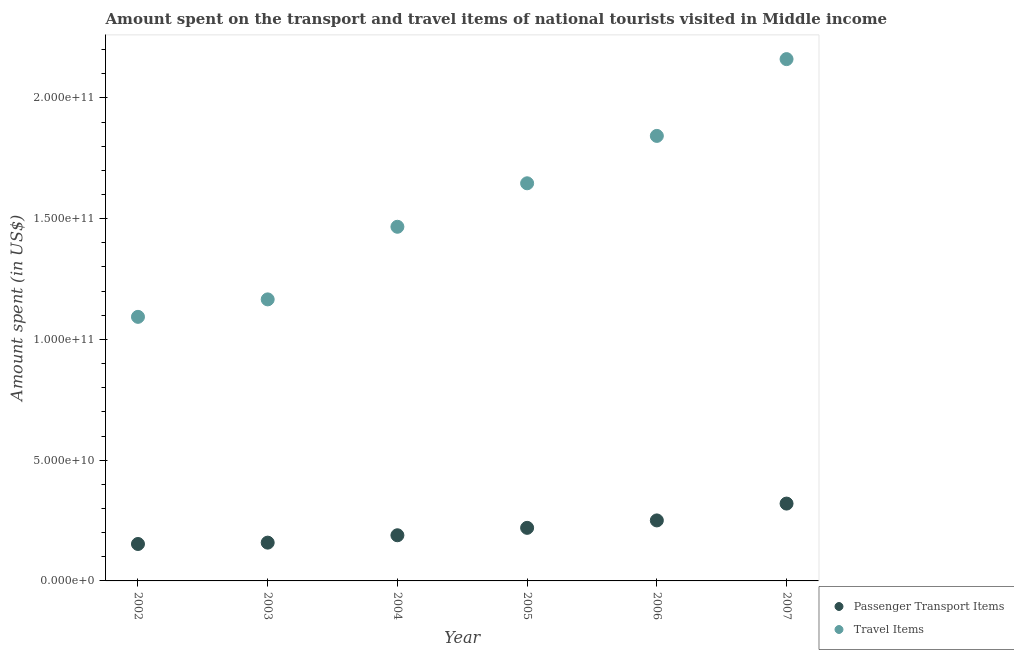How many different coloured dotlines are there?
Offer a very short reply. 2. What is the amount spent in travel items in 2003?
Keep it short and to the point. 1.17e+11. Across all years, what is the maximum amount spent in travel items?
Provide a short and direct response. 2.16e+11. Across all years, what is the minimum amount spent in travel items?
Make the answer very short. 1.09e+11. In which year was the amount spent on passenger transport items maximum?
Your answer should be very brief. 2007. In which year was the amount spent on passenger transport items minimum?
Provide a short and direct response. 2002. What is the total amount spent on passenger transport items in the graph?
Your answer should be very brief. 1.29e+11. What is the difference between the amount spent in travel items in 2003 and that in 2007?
Give a very brief answer. -9.95e+1. What is the difference between the amount spent on passenger transport items in 2006 and the amount spent in travel items in 2002?
Provide a short and direct response. -8.43e+1. What is the average amount spent in travel items per year?
Provide a succinct answer. 1.56e+11. In the year 2003, what is the difference between the amount spent on passenger transport items and amount spent in travel items?
Give a very brief answer. -1.01e+11. In how many years, is the amount spent on passenger transport items greater than 80000000000 US$?
Provide a short and direct response. 0. What is the ratio of the amount spent on passenger transport items in 2002 to that in 2004?
Your answer should be compact. 0.81. Is the amount spent in travel items in 2003 less than that in 2004?
Your answer should be very brief. Yes. Is the difference between the amount spent in travel items in 2003 and 2007 greater than the difference between the amount spent on passenger transport items in 2003 and 2007?
Your answer should be very brief. No. What is the difference between the highest and the second highest amount spent on passenger transport items?
Provide a short and direct response. 6.97e+09. What is the difference between the highest and the lowest amount spent in travel items?
Make the answer very short. 1.07e+11. Is the sum of the amount spent in travel items in 2003 and 2006 greater than the maximum amount spent on passenger transport items across all years?
Make the answer very short. Yes. Is the amount spent on passenger transport items strictly less than the amount spent in travel items over the years?
Provide a short and direct response. Yes. How many years are there in the graph?
Give a very brief answer. 6. What is the difference between two consecutive major ticks on the Y-axis?
Make the answer very short. 5.00e+1. Are the values on the major ticks of Y-axis written in scientific E-notation?
Provide a succinct answer. Yes. What is the title of the graph?
Give a very brief answer. Amount spent on the transport and travel items of national tourists visited in Middle income. What is the label or title of the X-axis?
Your response must be concise. Year. What is the label or title of the Y-axis?
Your answer should be very brief. Amount spent (in US$). What is the Amount spent (in US$) of Passenger Transport Items in 2002?
Provide a succinct answer. 1.53e+1. What is the Amount spent (in US$) in Travel Items in 2002?
Provide a short and direct response. 1.09e+11. What is the Amount spent (in US$) in Passenger Transport Items in 2003?
Ensure brevity in your answer.  1.59e+1. What is the Amount spent (in US$) in Travel Items in 2003?
Provide a short and direct response. 1.17e+11. What is the Amount spent (in US$) in Passenger Transport Items in 2004?
Provide a succinct answer. 1.89e+1. What is the Amount spent (in US$) in Travel Items in 2004?
Offer a terse response. 1.47e+11. What is the Amount spent (in US$) of Passenger Transport Items in 2005?
Provide a short and direct response. 2.20e+1. What is the Amount spent (in US$) in Travel Items in 2005?
Offer a very short reply. 1.65e+11. What is the Amount spent (in US$) in Passenger Transport Items in 2006?
Your answer should be very brief. 2.51e+1. What is the Amount spent (in US$) in Travel Items in 2006?
Ensure brevity in your answer.  1.84e+11. What is the Amount spent (in US$) in Passenger Transport Items in 2007?
Provide a succinct answer. 3.20e+1. What is the Amount spent (in US$) of Travel Items in 2007?
Provide a succinct answer. 2.16e+11. Across all years, what is the maximum Amount spent (in US$) of Passenger Transport Items?
Your response must be concise. 3.20e+1. Across all years, what is the maximum Amount spent (in US$) in Travel Items?
Ensure brevity in your answer.  2.16e+11. Across all years, what is the minimum Amount spent (in US$) in Passenger Transport Items?
Make the answer very short. 1.53e+1. Across all years, what is the minimum Amount spent (in US$) of Travel Items?
Give a very brief answer. 1.09e+11. What is the total Amount spent (in US$) in Passenger Transport Items in the graph?
Make the answer very short. 1.29e+11. What is the total Amount spent (in US$) in Travel Items in the graph?
Your answer should be very brief. 9.38e+11. What is the difference between the Amount spent (in US$) of Passenger Transport Items in 2002 and that in 2003?
Provide a succinct answer. -5.61e+08. What is the difference between the Amount spent (in US$) in Travel Items in 2002 and that in 2003?
Make the answer very short. -7.23e+09. What is the difference between the Amount spent (in US$) in Passenger Transport Items in 2002 and that in 2004?
Make the answer very short. -3.61e+09. What is the difference between the Amount spent (in US$) in Travel Items in 2002 and that in 2004?
Provide a succinct answer. -3.73e+1. What is the difference between the Amount spent (in US$) of Passenger Transport Items in 2002 and that in 2005?
Provide a short and direct response. -6.68e+09. What is the difference between the Amount spent (in US$) of Travel Items in 2002 and that in 2005?
Make the answer very short. -5.53e+1. What is the difference between the Amount spent (in US$) of Passenger Transport Items in 2002 and that in 2006?
Your answer should be very brief. -9.76e+09. What is the difference between the Amount spent (in US$) in Travel Items in 2002 and that in 2006?
Your answer should be very brief. -7.49e+1. What is the difference between the Amount spent (in US$) in Passenger Transport Items in 2002 and that in 2007?
Provide a succinct answer. -1.67e+1. What is the difference between the Amount spent (in US$) in Travel Items in 2002 and that in 2007?
Offer a very short reply. -1.07e+11. What is the difference between the Amount spent (in US$) of Passenger Transport Items in 2003 and that in 2004?
Ensure brevity in your answer.  -3.05e+09. What is the difference between the Amount spent (in US$) in Travel Items in 2003 and that in 2004?
Your response must be concise. -3.01e+1. What is the difference between the Amount spent (in US$) of Passenger Transport Items in 2003 and that in 2005?
Offer a terse response. -6.12e+09. What is the difference between the Amount spent (in US$) in Travel Items in 2003 and that in 2005?
Your answer should be very brief. -4.81e+1. What is the difference between the Amount spent (in US$) in Passenger Transport Items in 2003 and that in 2006?
Provide a succinct answer. -9.20e+09. What is the difference between the Amount spent (in US$) in Travel Items in 2003 and that in 2006?
Your answer should be very brief. -6.77e+1. What is the difference between the Amount spent (in US$) of Passenger Transport Items in 2003 and that in 2007?
Offer a very short reply. -1.62e+1. What is the difference between the Amount spent (in US$) of Travel Items in 2003 and that in 2007?
Your answer should be compact. -9.95e+1. What is the difference between the Amount spent (in US$) of Passenger Transport Items in 2004 and that in 2005?
Provide a succinct answer. -3.07e+09. What is the difference between the Amount spent (in US$) of Travel Items in 2004 and that in 2005?
Your answer should be very brief. -1.80e+1. What is the difference between the Amount spent (in US$) of Passenger Transport Items in 2004 and that in 2006?
Keep it short and to the point. -6.15e+09. What is the difference between the Amount spent (in US$) of Travel Items in 2004 and that in 2006?
Your answer should be compact. -3.76e+1. What is the difference between the Amount spent (in US$) in Passenger Transport Items in 2004 and that in 2007?
Your answer should be very brief. -1.31e+1. What is the difference between the Amount spent (in US$) in Travel Items in 2004 and that in 2007?
Your answer should be compact. -6.94e+1. What is the difference between the Amount spent (in US$) of Passenger Transport Items in 2005 and that in 2006?
Your answer should be very brief. -3.08e+09. What is the difference between the Amount spent (in US$) in Travel Items in 2005 and that in 2006?
Offer a very short reply. -1.96e+1. What is the difference between the Amount spent (in US$) in Passenger Transport Items in 2005 and that in 2007?
Offer a very short reply. -1.00e+1. What is the difference between the Amount spent (in US$) of Travel Items in 2005 and that in 2007?
Your answer should be very brief. -5.14e+1. What is the difference between the Amount spent (in US$) in Passenger Transport Items in 2006 and that in 2007?
Provide a succinct answer. -6.97e+09. What is the difference between the Amount spent (in US$) of Travel Items in 2006 and that in 2007?
Your answer should be compact. -3.18e+1. What is the difference between the Amount spent (in US$) of Passenger Transport Items in 2002 and the Amount spent (in US$) of Travel Items in 2003?
Provide a short and direct response. -1.01e+11. What is the difference between the Amount spent (in US$) of Passenger Transport Items in 2002 and the Amount spent (in US$) of Travel Items in 2004?
Provide a short and direct response. -1.31e+11. What is the difference between the Amount spent (in US$) of Passenger Transport Items in 2002 and the Amount spent (in US$) of Travel Items in 2005?
Your answer should be compact. -1.49e+11. What is the difference between the Amount spent (in US$) in Passenger Transport Items in 2002 and the Amount spent (in US$) in Travel Items in 2006?
Make the answer very short. -1.69e+11. What is the difference between the Amount spent (in US$) in Passenger Transport Items in 2002 and the Amount spent (in US$) in Travel Items in 2007?
Ensure brevity in your answer.  -2.01e+11. What is the difference between the Amount spent (in US$) of Passenger Transport Items in 2003 and the Amount spent (in US$) of Travel Items in 2004?
Your answer should be very brief. -1.31e+11. What is the difference between the Amount spent (in US$) in Passenger Transport Items in 2003 and the Amount spent (in US$) in Travel Items in 2005?
Your response must be concise. -1.49e+11. What is the difference between the Amount spent (in US$) in Passenger Transport Items in 2003 and the Amount spent (in US$) in Travel Items in 2006?
Make the answer very short. -1.68e+11. What is the difference between the Amount spent (in US$) of Passenger Transport Items in 2003 and the Amount spent (in US$) of Travel Items in 2007?
Ensure brevity in your answer.  -2.00e+11. What is the difference between the Amount spent (in US$) of Passenger Transport Items in 2004 and the Amount spent (in US$) of Travel Items in 2005?
Your answer should be compact. -1.46e+11. What is the difference between the Amount spent (in US$) in Passenger Transport Items in 2004 and the Amount spent (in US$) in Travel Items in 2006?
Your response must be concise. -1.65e+11. What is the difference between the Amount spent (in US$) of Passenger Transport Items in 2004 and the Amount spent (in US$) of Travel Items in 2007?
Offer a very short reply. -1.97e+11. What is the difference between the Amount spent (in US$) of Passenger Transport Items in 2005 and the Amount spent (in US$) of Travel Items in 2006?
Your response must be concise. -1.62e+11. What is the difference between the Amount spent (in US$) of Passenger Transport Items in 2005 and the Amount spent (in US$) of Travel Items in 2007?
Offer a terse response. -1.94e+11. What is the difference between the Amount spent (in US$) in Passenger Transport Items in 2006 and the Amount spent (in US$) in Travel Items in 2007?
Your answer should be compact. -1.91e+11. What is the average Amount spent (in US$) in Passenger Transport Items per year?
Your response must be concise. 2.15e+1. What is the average Amount spent (in US$) in Travel Items per year?
Your response must be concise. 1.56e+11. In the year 2002, what is the difference between the Amount spent (in US$) in Passenger Transport Items and Amount spent (in US$) in Travel Items?
Make the answer very short. -9.41e+1. In the year 2003, what is the difference between the Amount spent (in US$) in Passenger Transport Items and Amount spent (in US$) in Travel Items?
Your answer should be very brief. -1.01e+11. In the year 2004, what is the difference between the Amount spent (in US$) in Passenger Transport Items and Amount spent (in US$) in Travel Items?
Ensure brevity in your answer.  -1.28e+11. In the year 2005, what is the difference between the Amount spent (in US$) in Passenger Transport Items and Amount spent (in US$) in Travel Items?
Offer a very short reply. -1.43e+11. In the year 2006, what is the difference between the Amount spent (in US$) in Passenger Transport Items and Amount spent (in US$) in Travel Items?
Your answer should be compact. -1.59e+11. In the year 2007, what is the difference between the Amount spent (in US$) of Passenger Transport Items and Amount spent (in US$) of Travel Items?
Your answer should be compact. -1.84e+11. What is the ratio of the Amount spent (in US$) in Passenger Transport Items in 2002 to that in 2003?
Provide a short and direct response. 0.96. What is the ratio of the Amount spent (in US$) of Travel Items in 2002 to that in 2003?
Provide a short and direct response. 0.94. What is the ratio of the Amount spent (in US$) of Passenger Transport Items in 2002 to that in 2004?
Your answer should be compact. 0.81. What is the ratio of the Amount spent (in US$) in Travel Items in 2002 to that in 2004?
Your response must be concise. 0.75. What is the ratio of the Amount spent (in US$) of Passenger Transport Items in 2002 to that in 2005?
Provide a succinct answer. 0.7. What is the ratio of the Amount spent (in US$) of Travel Items in 2002 to that in 2005?
Your answer should be compact. 0.66. What is the ratio of the Amount spent (in US$) in Passenger Transport Items in 2002 to that in 2006?
Ensure brevity in your answer.  0.61. What is the ratio of the Amount spent (in US$) in Travel Items in 2002 to that in 2006?
Your answer should be very brief. 0.59. What is the ratio of the Amount spent (in US$) of Passenger Transport Items in 2002 to that in 2007?
Provide a succinct answer. 0.48. What is the ratio of the Amount spent (in US$) of Travel Items in 2002 to that in 2007?
Provide a succinct answer. 0.51. What is the ratio of the Amount spent (in US$) of Passenger Transport Items in 2003 to that in 2004?
Make the answer very short. 0.84. What is the ratio of the Amount spent (in US$) in Travel Items in 2003 to that in 2004?
Offer a very short reply. 0.8. What is the ratio of the Amount spent (in US$) of Passenger Transport Items in 2003 to that in 2005?
Keep it short and to the point. 0.72. What is the ratio of the Amount spent (in US$) of Travel Items in 2003 to that in 2005?
Offer a terse response. 0.71. What is the ratio of the Amount spent (in US$) in Passenger Transport Items in 2003 to that in 2006?
Ensure brevity in your answer.  0.63. What is the ratio of the Amount spent (in US$) of Travel Items in 2003 to that in 2006?
Your answer should be very brief. 0.63. What is the ratio of the Amount spent (in US$) in Passenger Transport Items in 2003 to that in 2007?
Provide a short and direct response. 0.5. What is the ratio of the Amount spent (in US$) of Travel Items in 2003 to that in 2007?
Provide a succinct answer. 0.54. What is the ratio of the Amount spent (in US$) of Passenger Transport Items in 2004 to that in 2005?
Offer a terse response. 0.86. What is the ratio of the Amount spent (in US$) in Travel Items in 2004 to that in 2005?
Your answer should be compact. 0.89. What is the ratio of the Amount spent (in US$) of Passenger Transport Items in 2004 to that in 2006?
Keep it short and to the point. 0.75. What is the ratio of the Amount spent (in US$) of Travel Items in 2004 to that in 2006?
Provide a succinct answer. 0.8. What is the ratio of the Amount spent (in US$) of Passenger Transport Items in 2004 to that in 2007?
Provide a succinct answer. 0.59. What is the ratio of the Amount spent (in US$) in Travel Items in 2004 to that in 2007?
Your response must be concise. 0.68. What is the ratio of the Amount spent (in US$) in Passenger Transport Items in 2005 to that in 2006?
Offer a terse response. 0.88. What is the ratio of the Amount spent (in US$) of Travel Items in 2005 to that in 2006?
Your answer should be very brief. 0.89. What is the ratio of the Amount spent (in US$) in Passenger Transport Items in 2005 to that in 2007?
Ensure brevity in your answer.  0.69. What is the ratio of the Amount spent (in US$) in Travel Items in 2005 to that in 2007?
Give a very brief answer. 0.76. What is the ratio of the Amount spent (in US$) in Passenger Transport Items in 2006 to that in 2007?
Provide a succinct answer. 0.78. What is the ratio of the Amount spent (in US$) of Travel Items in 2006 to that in 2007?
Keep it short and to the point. 0.85. What is the difference between the highest and the second highest Amount spent (in US$) of Passenger Transport Items?
Offer a very short reply. 6.97e+09. What is the difference between the highest and the second highest Amount spent (in US$) of Travel Items?
Your answer should be compact. 3.18e+1. What is the difference between the highest and the lowest Amount spent (in US$) of Passenger Transport Items?
Provide a short and direct response. 1.67e+1. What is the difference between the highest and the lowest Amount spent (in US$) of Travel Items?
Offer a terse response. 1.07e+11. 